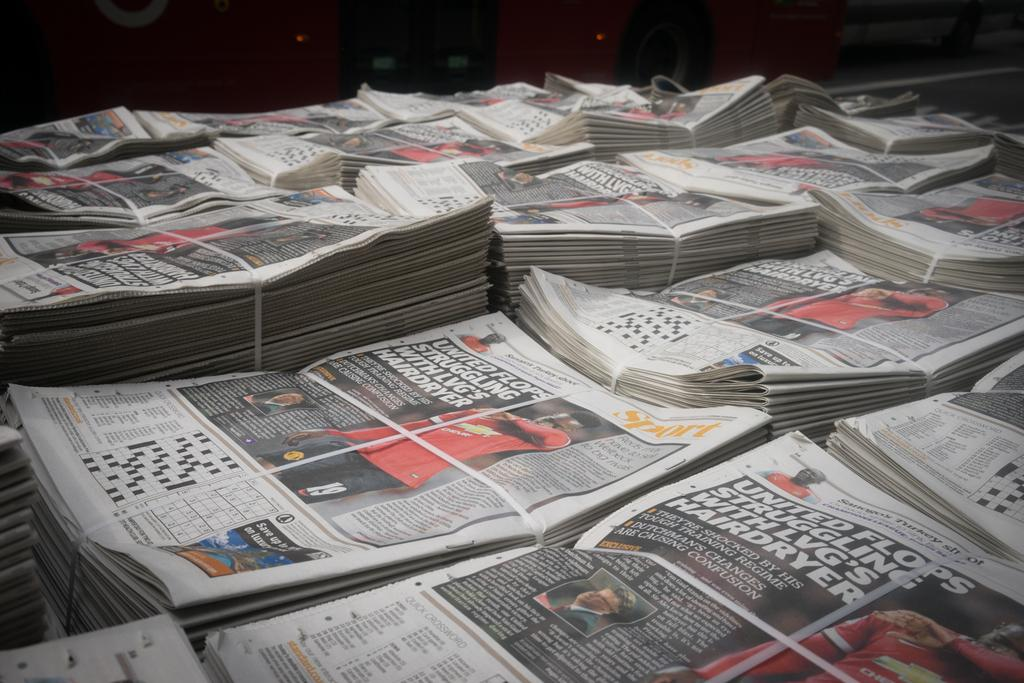Provide a one-sentence caption for the provided image. Stacks of newspapers displaying a story about United Football club are tied together. 